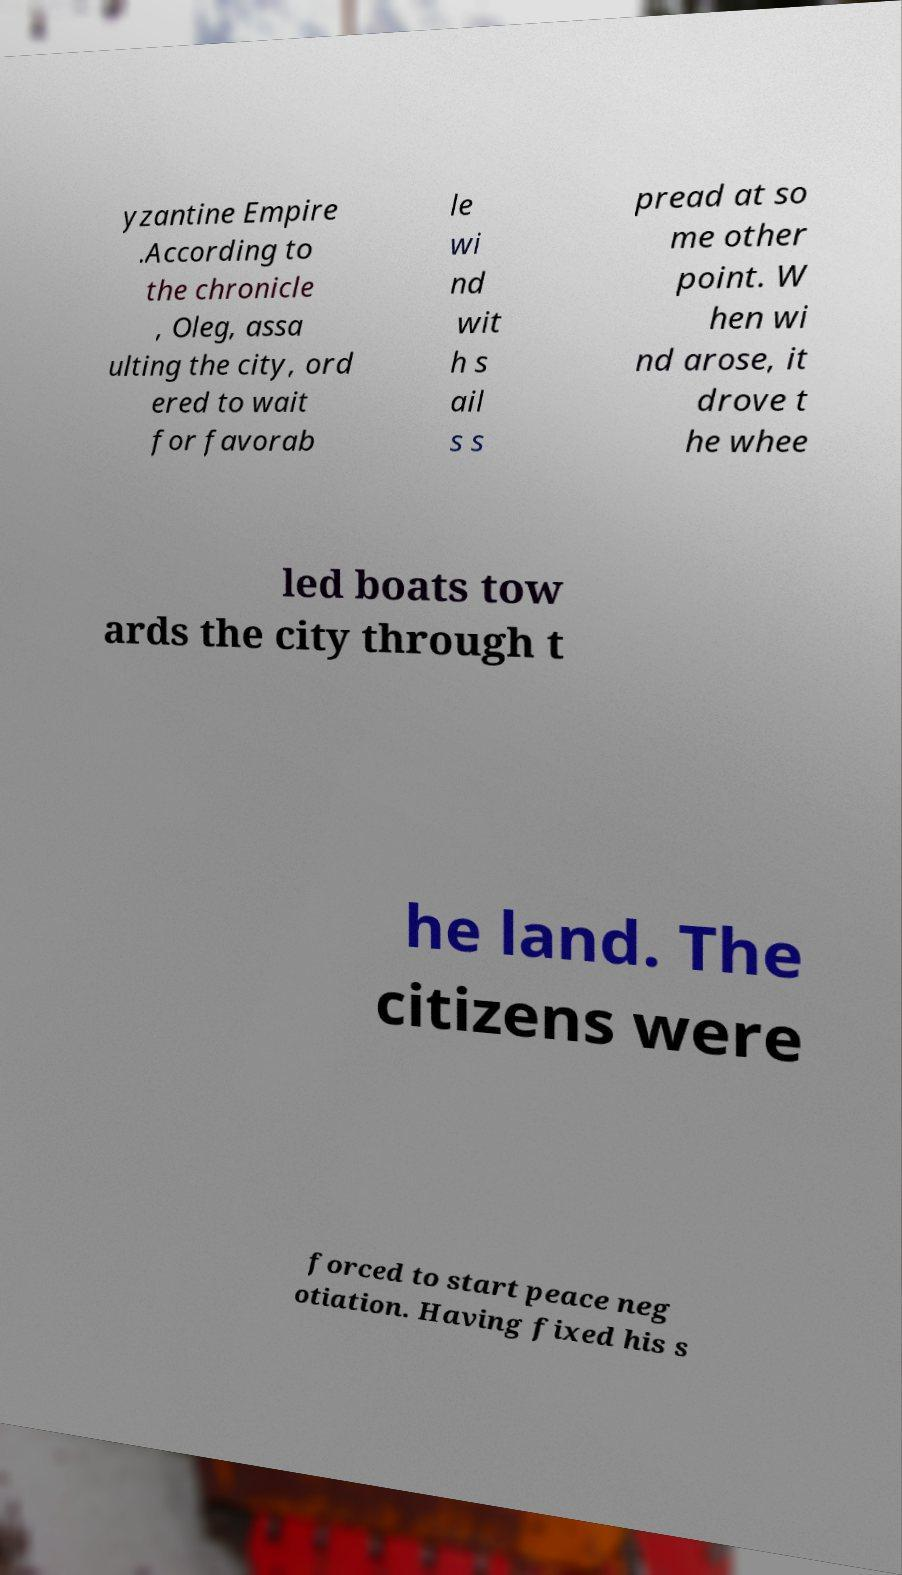For documentation purposes, I need the text within this image transcribed. Could you provide that? yzantine Empire .According to the chronicle , Oleg, assa ulting the city, ord ered to wait for favorab le wi nd wit h s ail s s pread at so me other point. W hen wi nd arose, it drove t he whee led boats tow ards the city through t he land. The citizens were forced to start peace neg otiation. Having fixed his s 